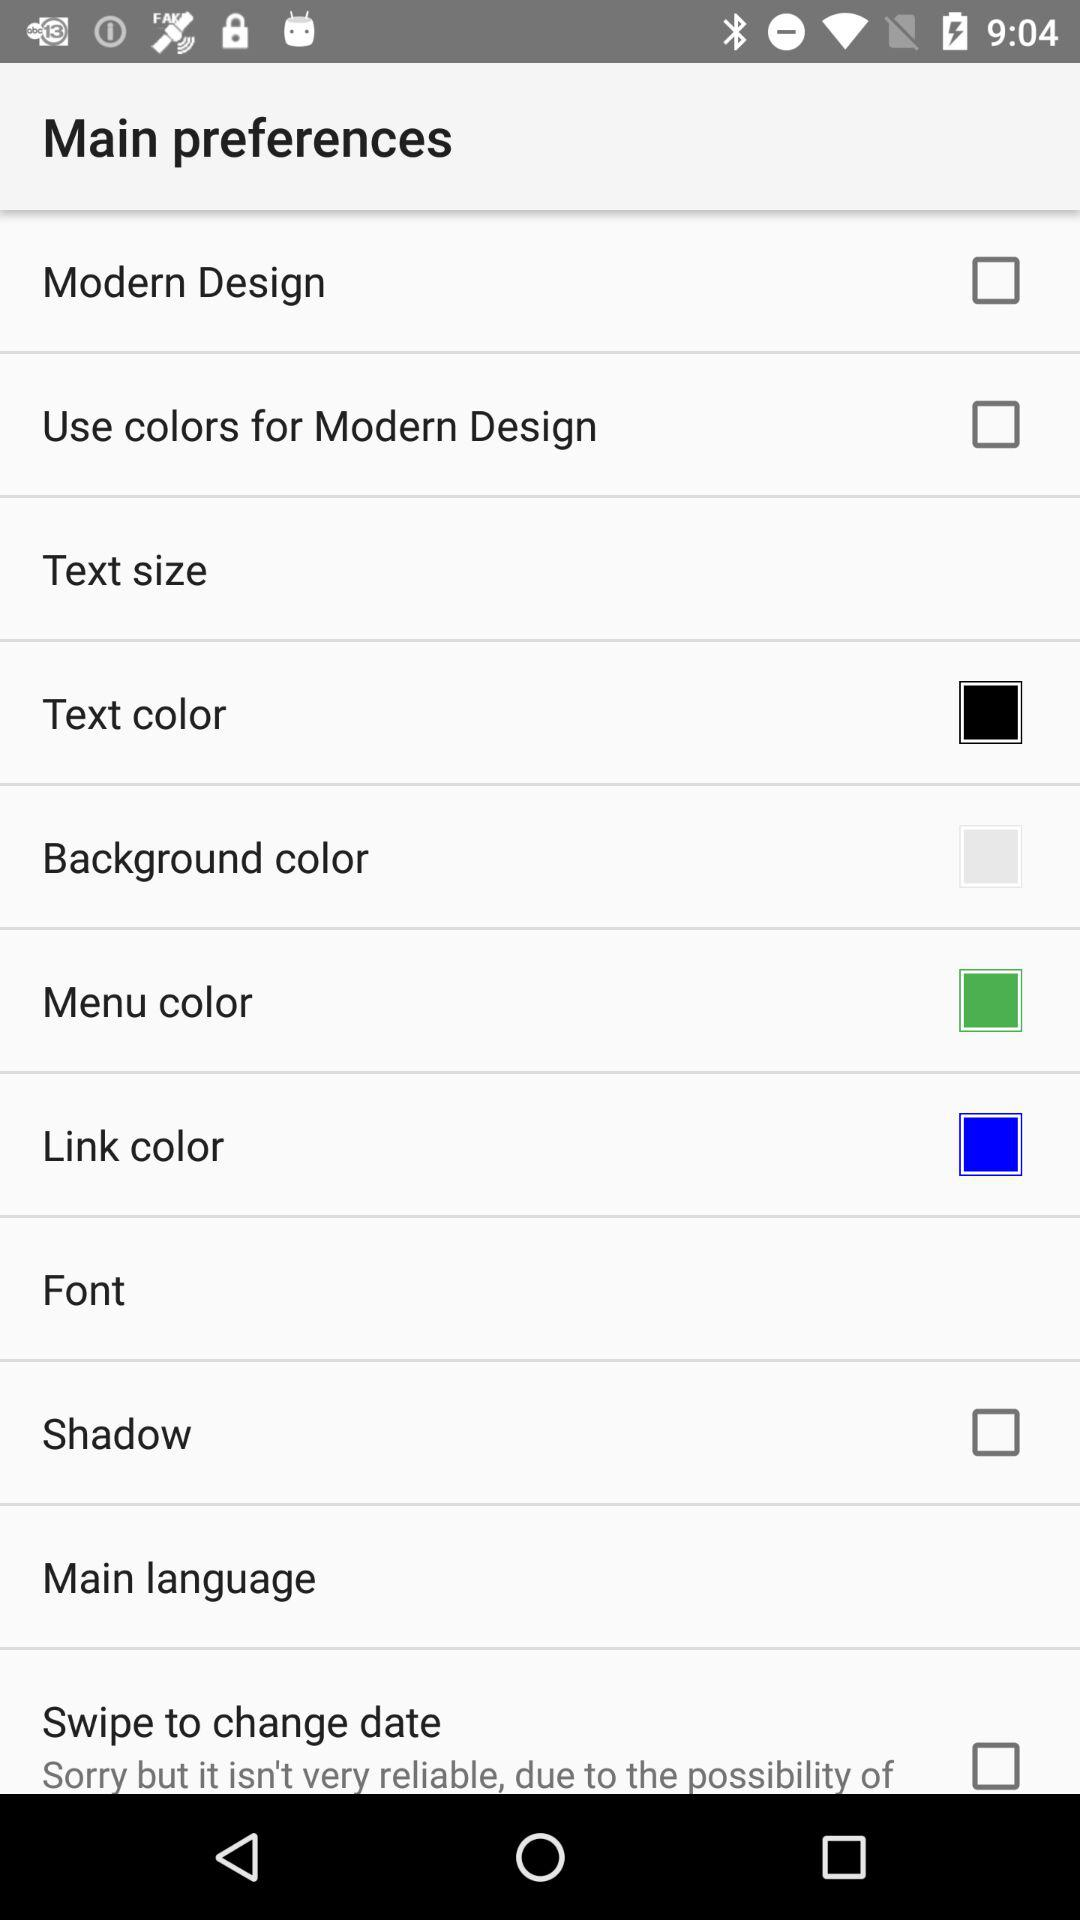What is the status of "Shadow"? The status of "Shadow" is "off". 